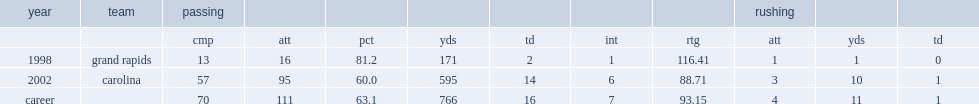How many touchdown passes did sparrow record in the 2002 season? 14.0. 